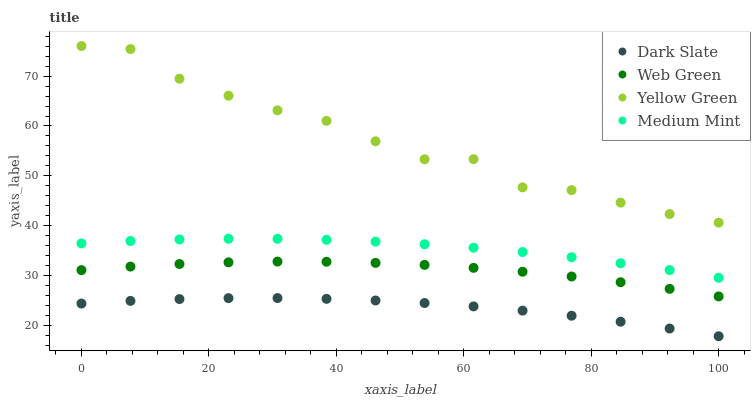Does Dark Slate have the minimum area under the curve?
Answer yes or no. Yes. Does Yellow Green have the maximum area under the curve?
Answer yes or no. Yes. Does Yellow Green have the minimum area under the curve?
Answer yes or no. No. Does Dark Slate have the maximum area under the curve?
Answer yes or no. No. Is Medium Mint the smoothest?
Answer yes or no. Yes. Is Yellow Green the roughest?
Answer yes or no. Yes. Is Dark Slate the smoothest?
Answer yes or no. No. Is Dark Slate the roughest?
Answer yes or no. No. Does Dark Slate have the lowest value?
Answer yes or no. Yes. Does Yellow Green have the lowest value?
Answer yes or no. No. Does Yellow Green have the highest value?
Answer yes or no. Yes. Does Dark Slate have the highest value?
Answer yes or no. No. Is Dark Slate less than Medium Mint?
Answer yes or no. Yes. Is Yellow Green greater than Dark Slate?
Answer yes or no. Yes. Does Dark Slate intersect Medium Mint?
Answer yes or no. No. 